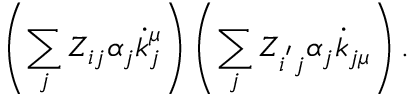Convert formula to latex. <formula><loc_0><loc_0><loc_500><loc_500>\left ( \sum _ { j } Z _ { i j } \alpha _ { j } \dot { k } _ { j } ^ { \mu } \right ) \left ( \sum _ { j } Z _ { i ^ { ^ { \prime } } j } \alpha _ { j } \dot { k } _ { j \mu } \right ) .</formula> 